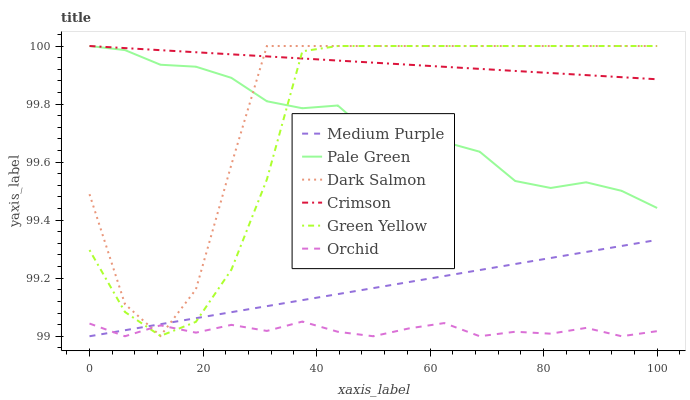Does Medium Purple have the minimum area under the curve?
Answer yes or no. No. Does Medium Purple have the maximum area under the curve?
Answer yes or no. No. Is Pale Green the smoothest?
Answer yes or no. No. Is Pale Green the roughest?
Answer yes or no. No. Does Pale Green have the lowest value?
Answer yes or no. No. Does Medium Purple have the highest value?
Answer yes or no. No. Is Medium Purple less than Crimson?
Answer yes or no. Yes. Is Crimson greater than Medium Purple?
Answer yes or no. Yes. Does Medium Purple intersect Crimson?
Answer yes or no. No. 